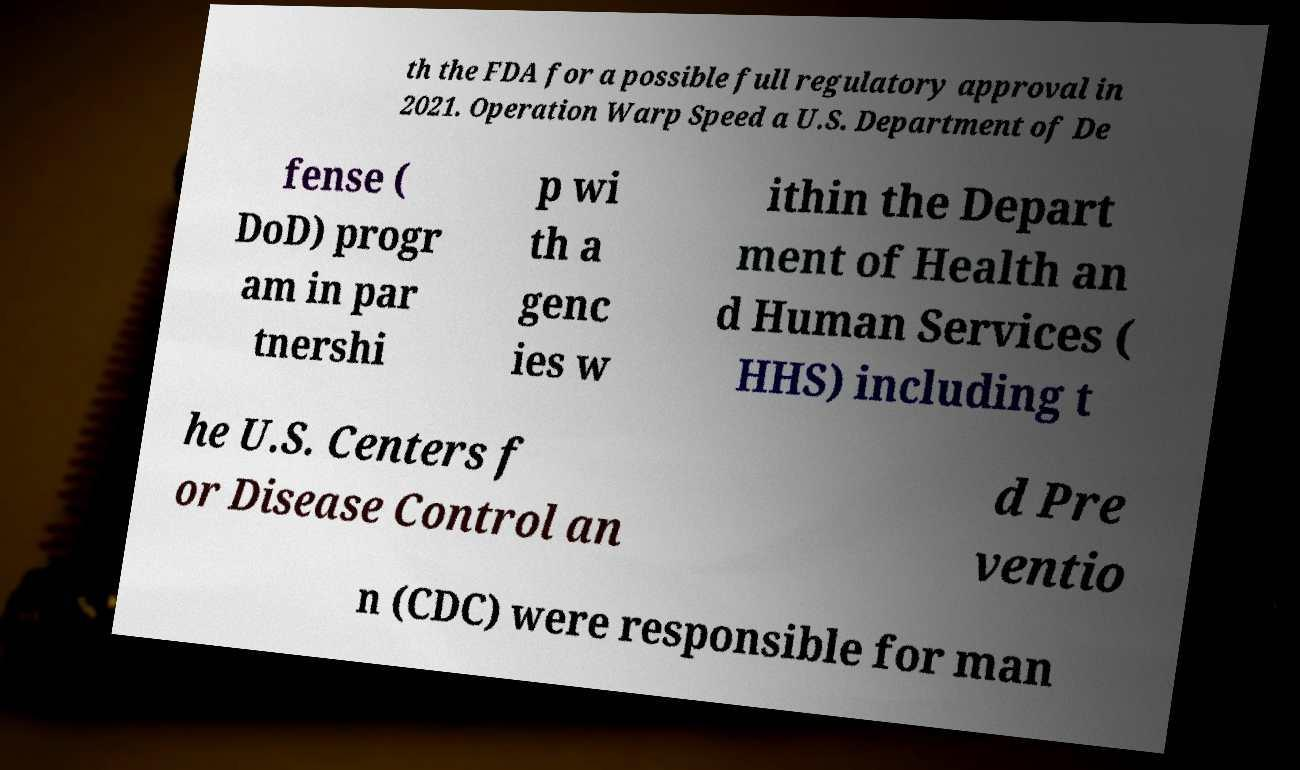Please identify and transcribe the text found in this image. th the FDA for a possible full regulatory approval in 2021. Operation Warp Speed a U.S. Department of De fense ( DoD) progr am in par tnershi p wi th a genc ies w ithin the Depart ment of Health an d Human Services ( HHS) including t he U.S. Centers f or Disease Control an d Pre ventio n (CDC) were responsible for man 